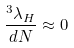<formula> <loc_0><loc_0><loc_500><loc_500>\frac { ^ { 3 } \lambda _ { H } } { d N } \approx 0</formula> 